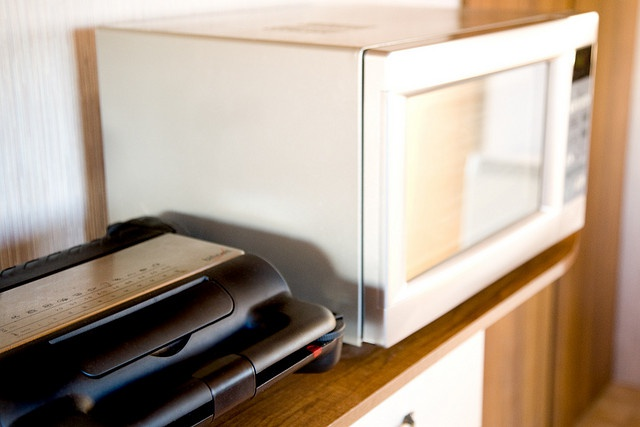Describe the objects in this image and their specific colors. I can see a microwave in lightgray, ivory, tan, and gray tones in this image. 